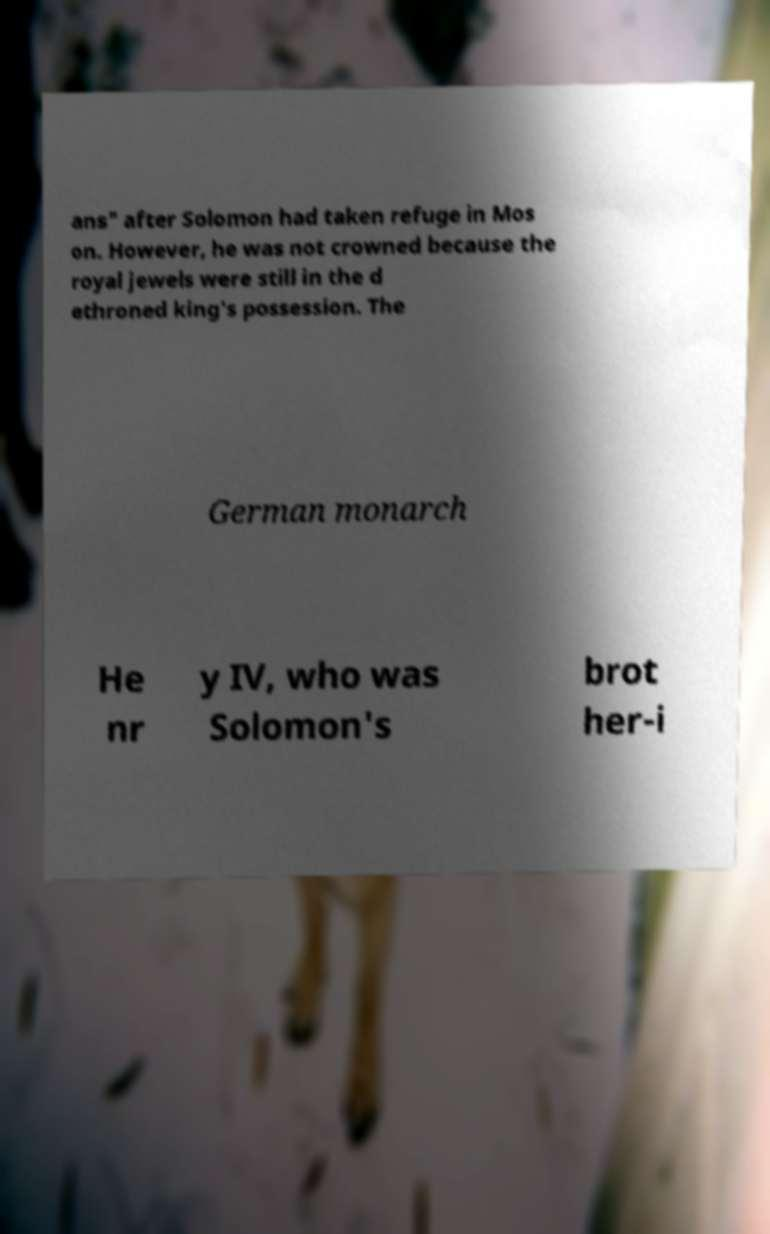Could you assist in decoding the text presented in this image and type it out clearly? ans" after Solomon had taken refuge in Mos on. However, he was not crowned because the royal jewels were still in the d ethroned king's possession. The German monarch He nr y IV, who was Solomon's brot her-i 